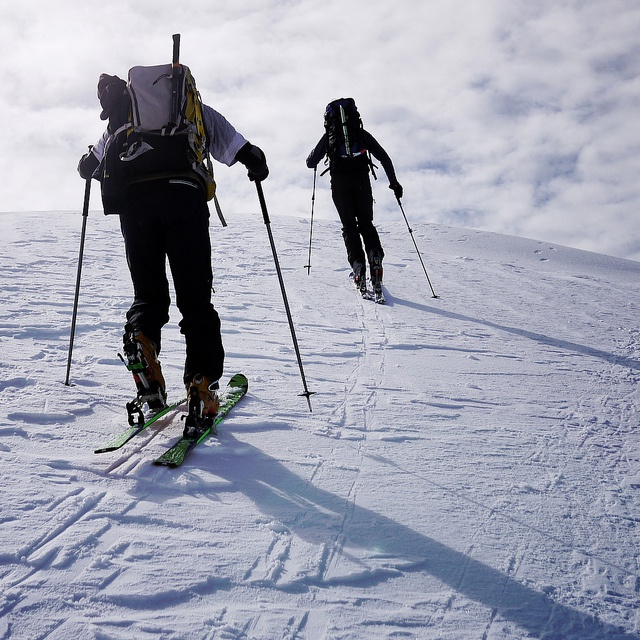Describe the objects in this image and their specific colors. I can see people in white, black, gray, and lightgray tones, backpack in white, black, gray, and lightgray tones, people in white, black, lightgray, gray, and darkgray tones, skis in white, black, purple, darkgreen, and darkgray tones, and backpack in white, black, gray, lightgray, and darkgray tones in this image. 